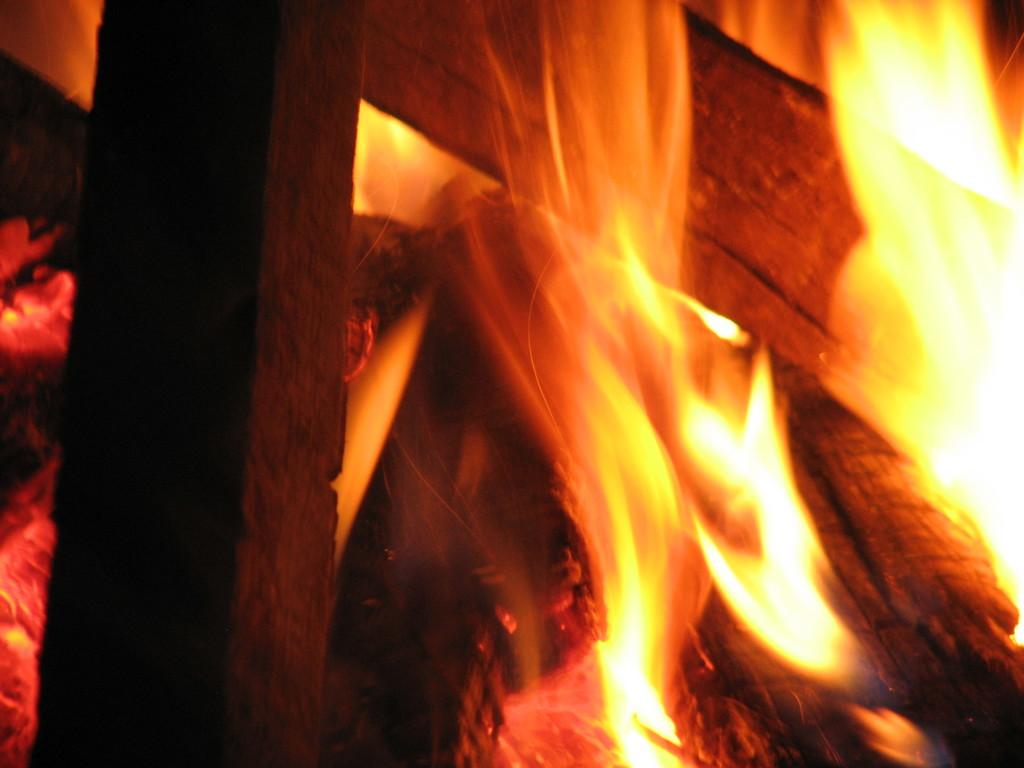What type of material is used to create the pieces in the image? The pieces in the image are made of wood. What is happening to the wooden pieces in the image? The wooden pieces have fire on them. What is the size of the butter in the image? There is no butter present in the image. 